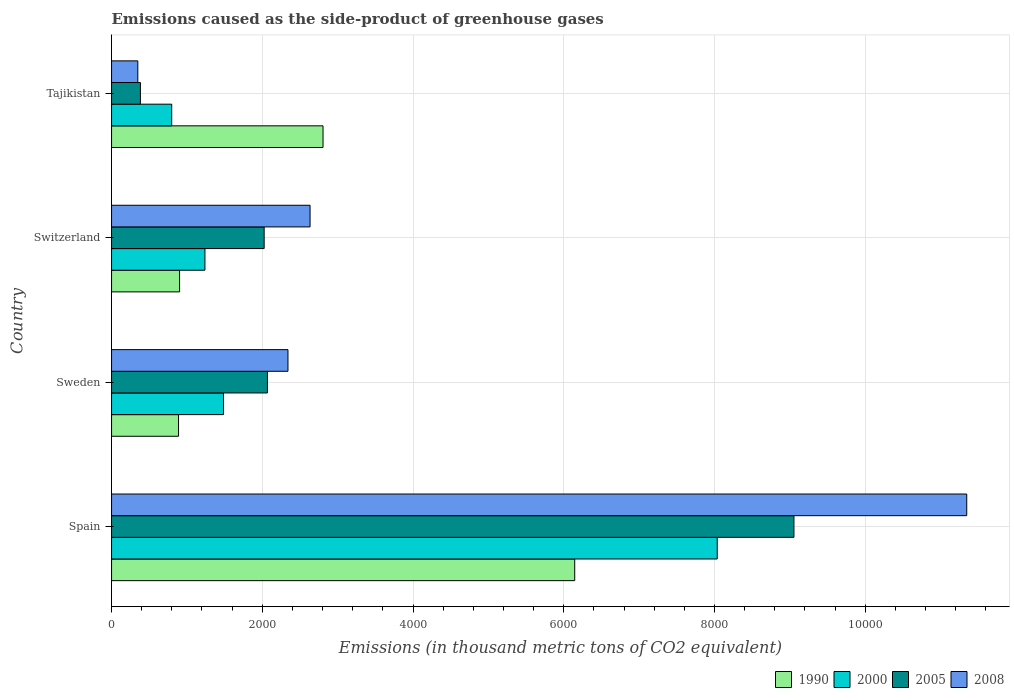How many groups of bars are there?
Your response must be concise. 4. Are the number of bars per tick equal to the number of legend labels?
Give a very brief answer. Yes. What is the label of the 1st group of bars from the top?
Your answer should be compact. Tajikistan. In how many cases, is the number of bars for a given country not equal to the number of legend labels?
Your answer should be very brief. 0. What is the emissions caused as the side-product of greenhouse gases in 2008 in Switzerland?
Offer a very short reply. 2634.1. Across all countries, what is the maximum emissions caused as the side-product of greenhouse gases in 1990?
Make the answer very short. 6146. Across all countries, what is the minimum emissions caused as the side-product of greenhouse gases in 1990?
Keep it short and to the point. 888.6. In which country was the emissions caused as the side-product of greenhouse gases in 2000 maximum?
Make the answer very short. Spain. In which country was the emissions caused as the side-product of greenhouse gases in 2005 minimum?
Offer a very short reply. Tajikistan. What is the total emissions caused as the side-product of greenhouse gases in 1990 in the graph?
Offer a very short reply. 1.07e+04. What is the difference between the emissions caused as the side-product of greenhouse gases in 2008 in Spain and that in Tajikistan?
Ensure brevity in your answer.  1.10e+04. What is the difference between the emissions caused as the side-product of greenhouse gases in 2005 in Tajikistan and the emissions caused as the side-product of greenhouse gases in 1990 in Sweden?
Make the answer very short. -505.6. What is the average emissions caused as the side-product of greenhouse gases in 1990 per country?
Offer a terse response. 2685.83. What is the difference between the emissions caused as the side-product of greenhouse gases in 2000 and emissions caused as the side-product of greenhouse gases in 2005 in Sweden?
Offer a terse response. -583.1. In how many countries, is the emissions caused as the side-product of greenhouse gases in 1990 greater than 9600 thousand metric tons?
Ensure brevity in your answer.  0. What is the ratio of the emissions caused as the side-product of greenhouse gases in 2008 in Sweden to that in Tajikistan?
Keep it short and to the point. 6.72. Is the emissions caused as the side-product of greenhouse gases in 2008 in Spain less than that in Switzerland?
Ensure brevity in your answer.  No. Is the difference between the emissions caused as the side-product of greenhouse gases in 2000 in Spain and Switzerland greater than the difference between the emissions caused as the side-product of greenhouse gases in 2005 in Spain and Switzerland?
Offer a very short reply. No. What is the difference between the highest and the second highest emissions caused as the side-product of greenhouse gases in 1990?
Make the answer very short. 3339.9. What is the difference between the highest and the lowest emissions caused as the side-product of greenhouse gases in 2000?
Keep it short and to the point. 7239.1. What does the 3rd bar from the top in Spain represents?
Your response must be concise. 2000. What does the 4th bar from the bottom in Switzerland represents?
Your answer should be very brief. 2008. Is it the case that in every country, the sum of the emissions caused as the side-product of greenhouse gases in 2005 and emissions caused as the side-product of greenhouse gases in 2008 is greater than the emissions caused as the side-product of greenhouse gases in 2000?
Your answer should be very brief. No. How many bars are there?
Offer a very short reply. 16. How many countries are there in the graph?
Your answer should be compact. 4. What is the difference between two consecutive major ticks on the X-axis?
Offer a very short reply. 2000. Does the graph contain any zero values?
Make the answer very short. No. Does the graph contain grids?
Offer a very short reply. Yes. Where does the legend appear in the graph?
Ensure brevity in your answer.  Bottom right. How are the legend labels stacked?
Your answer should be compact. Horizontal. What is the title of the graph?
Provide a short and direct response. Emissions caused as the side-product of greenhouse gases. What is the label or title of the X-axis?
Make the answer very short. Emissions (in thousand metric tons of CO2 equivalent). What is the label or title of the Y-axis?
Ensure brevity in your answer.  Country. What is the Emissions (in thousand metric tons of CO2 equivalent) in 1990 in Spain?
Make the answer very short. 6146. What is the Emissions (in thousand metric tons of CO2 equivalent) of 2000 in Spain?
Make the answer very short. 8037.1. What is the Emissions (in thousand metric tons of CO2 equivalent) in 2005 in Spain?
Keep it short and to the point. 9055.1. What is the Emissions (in thousand metric tons of CO2 equivalent) in 2008 in Spain?
Keep it short and to the point. 1.13e+04. What is the Emissions (in thousand metric tons of CO2 equivalent) in 1990 in Sweden?
Provide a succinct answer. 888.6. What is the Emissions (in thousand metric tons of CO2 equivalent) of 2000 in Sweden?
Your answer should be compact. 1485.3. What is the Emissions (in thousand metric tons of CO2 equivalent) in 2005 in Sweden?
Provide a short and direct response. 2068.4. What is the Emissions (in thousand metric tons of CO2 equivalent) in 2008 in Sweden?
Offer a very short reply. 2340.9. What is the Emissions (in thousand metric tons of CO2 equivalent) of 1990 in Switzerland?
Offer a terse response. 902.6. What is the Emissions (in thousand metric tons of CO2 equivalent) of 2000 in Switzerland?
Keep it short and to the point. 1239.2. What is the Emissions (in thousand metric tons of CO2 equivalent) in 2005 in Switzerland?
Your answer should be very brief. 2025. What is the Emissions (in thousand metric tons of CO2 equivalent) of 2008 in Switzerland?
Offer a terse response. 2634.1. What is the Emissions (in thousand metric tons of CO2 equivalent) of 1990 in Tajikistan?
Make the answer very short. 2806.1. What is the Emissions (in thousand metric tons of CO2 equivalent) in 2000 in Tajikistan?
Provide a short and direct response. 798. What is the Emissions (in thousand metric tons of CO2 equivalent) of 2005 in Tajikistan?
Provide a short and direct response. 383. What is the Emissions (in thousand metric tons of CO2 equivalent) of 2008 in Tajikistan?
Provide a short and direct response. 348.3. Across all countries, what is the maximum Emissions (in thousand metric tons of CO2 equivalent) in 1990?
Your answer should be compact. 6146. Across all countries, what is the maximum Emissions (in thousand metric tons of CO2 equivalent) in 2000?
Offer a very short reply. 8037.1. Across all countries, what is the maximum Emissions (in thousand metric tons of CO2 equivalent) in 2005?
Your answer should be compact. 9055.1. Across all countries, what is the maximum Emissions (in thousand metric tons of CO2 equivalent) in 2008?
Provide a succinct answer. 1.13e+04. Across all countries, what is the minimum Emissions (in thousand metric tons of CO2 equivalent) in 1990?
Ensure brevity in your answer.  888.6. Across all countries, what is the minimum Emissions (in thousand metric tons of CO2 equivalent) in 2000?
Provide a short and direct response. 798. Across all countries, what is the minimum Emissions (in thousand metric tons of CO2 equivalent) of 2005?
Offer a very short reply. 383. Across all countries, what is the minimum Emissions (in thousand metric tons of CO2 equivalent) of 2008?
Your answer should be compact. 348.3. What is the total Emissions (in thousand metric tons of CO2 equivalent) in 1990 in the graph?
Your answer should be very brief. 1.07e+04. What is the total Emissions (in thousand metric tons of CO2 equivalent) of 2000 in the graph?
Provide a succinct answer. 1.16e+04. What is the total Emissions (in thousand metric tons of CO2 equivalent) in 2005 in the graph?
Give a very brief answer. 1.35e+04. What is the total Emissions (in thousand metric tons of CO2 equivalent) of 2008 in the graph?
Provide a succinct answer. 1.67e+04. What is the difference between the Emissions (in thousand metric tons of CO2 equivalent) of 1990 in Spain and that in Sweden?
Provide a short and direct response. 5257.4. What is the difference between the Emissions (in thousand metric tons of CO2 equivalent) of 2000 in Spain and that in Sweden?
Ensure brevity in your answer.  6551.8. What is the difference between the Emissions (in thousand metric tons of CO2 equivalent) in 2005 in Spain and that in Sweden?
Ensure brevity in your answer.  6986.7. What is the difference between the Emissions (in thousand metric tons of CO2 equivalent) in 2008 in Spain and that in Sweden?
Ensure brevity in your answer.  9006.9. What is the difference between the Emissions (in thousand metric tons of CO2 equivalent) of 1990 in Spain and that in Switzerland?
Offer a terse response. 5243.4. What is the difference between the Emissions (in thousand metric tons of CO2 equivalent) of 2000 in Spain and that in Switzerland?
Your answer should be very brief. 6797.9. What is the difference between the Emissions (in thousand metric tons of CO2 equivalent) of 2005 in Spain and that in Switzerland?
Give a very brief answer. 7030.1. What is the difference between the Emissions (in thousand metric tons of CO2 equivalent) of 2008 in Spain and that in Switzerland?
Your answer should be very brief. 8713.7. What is the difference between the Emissions (in thousand metric tons of CO2 equivalent) in 1990 in Spain and that in Tajikistan?
Ensure brevity in your answer.  3339.9. What is the difference between the Emissions (in thousand metric tons of CO2 equivalent) of 2000 in Spain and that in Tajikistan?
Keep it short and to the point. 7239.1. What is the difference between the Emissions (in thousand metric tons of CO2 equivalent) in 2005 in Spain and that in Tajikistan?
Provide a succinct answer. 8672.1. What is the difference between the Emissions (in thousand metric tons of CO2 equivalent) in 2008 in Spain and that in Tajikistan?
Offer a terse response. 1.10e+04. What is the difference between the Emissions (in thousand metric tons of CO2 equivalent) of 1990 in Sweden and that in Switzerland?
Offer a very short reply. -14. What is the difference between the Emissions (in thousand metric tons of CO2 equivalent) of 2000 in Sweden and that in Switzerland?
Keep it short and to the point. 246.1. What is the difference between the Emissions (in thousand metric tons of CO2 equivalent) of 2005 in Sweden and that in Switzerland?
Provide a succinct answer. 43.4. What is the difference between the Emissions (in thousand metric tons of CO2 equivalent) of 2008 in Sweden and that in Switzerland?
Your answer should be compact. -293.2. What is the difference between the Emissions (in thousand metric tons of CO2 equivalent) of 1990 in Sweden and that in Tajikistan?
Your answer should be very brief. -1917.5. What is the difference between the Emissions (in thousand metric tons of CO2 equivalent) in 2000 in Sweden and that in Tajikistan?
Keep it short and to the point. 687.3. What is the difference between the Emissions (in thousand metric tons of CO2 equivalent) in 2005 in Sweden and that in Tajikistan?
Keep it short and to the point. 1685.4. What is the difference between the Emissions (in thousand metric tons of CO2 equivalent) in 2008 in Sweden and that in Tajikistan?
Make the answer very short. 1992.6. What is the difference between the Emissions (in thousand metric tons of CO2 equivalent) of 1990 in Switzerland and that in Tajikistan?
Offer a terse response. -1903.5. What is the difference between the Emissions (in thousand metric tons of CO2 equivalent) in 2000 in Switzerland and that in Tajikistan?
Make the answer very short. 441.2. What is the difference between the Emissions (in thousand metric tons of CO2 equivalent) in 2005 in Switzerland and that in Tajikistan?
Provide a succinct answer. 1642. What is the difference between the Emissions (in thousand metric tons of CO2 equivalent) in 2008 in Switzerland and that in Tajikistan?
Offer a terse response. 2285.8. What is the difference between the Emissions (in thousand metric tons of CO2 equivalent) of 1990 in Spain and the Emissions (in thousand metric tons of CO2 equivalent) of 2000 in Sweden?
Ensure brevity in your answer.  4660.7. What is the difference between the Emissions (in thousand metric tons of CO2 equivalent) of 1990 in Spain and the Emissions (in thousand metric tons of CO2 equivalent) of 2005 in Sweden?
Offer a very short reply. 4077.6. What is the difference between the Emissions (in thousand metric tons of CO2 equivalent) in 1990 in Spain and the Emissions (in thousand metric tons of CO2 equivalent) in 2008 in Sweden?
Your answer should be compact. 3805.1. What is the difference between the Emissions (in thousand metric tons of CO2 equivalent) in 2000 in Spain and the Emissions (in thousand metric tons of CO2 equivalent) in 2005 in Sweden?
Give a very brief answer. 5968.7. What is the difference between the Emissions (in thousand metric tons of CO2 equivalent) in 2000 in Spain and the Emissions (in thousand metric tons of CO2 equivalent) in 2008 in Sweden?
Offer a terse response. 5696.2. What is the difference between the Emissions (in thousand metric tons of CO2 equivalent) of 2005 in Spain and the Emissions (in thousand metric tons of CO2 equivalent) of 2008 in Sweden?
Offer a terse response. 6714.2. What is the difference between the Emissions (in thousand metric tons of CO2 equivalent) of 1990 in Spain and the Emissions (in thousand metric tons of CO2 equivalent) of 2000 in Switzerland?
Your answer should be compact. 4906.8. What is the difference between the Emissions (in thousand metric tons of CO2 equivalent) in 1990 in Spain and the Emissions (in thousand metric tons of CO2 equivalent) in 2005 in Switzerland?
Provide a short and direct response. 4121. What is the difference between the Emissions (in thousand metric tons of CO2 equivalent) of 1990 in Spain and the Emissions (in thousand metric tons of CO2 equivalent) of 2008 in Switzerland?
Offer a very short reply. 3511.9. What is the difference between the Emissions (in thousand metric tons of CO2 equivalent) in 2000 in Spain and the Emissions (in thousand metric tons of CO2 equivalent) in 2005 in Switzerland?
Provide a succinct answer. 6012.1. What is the difference between the Emissions (in thousand metric tons of CO2 equivalent) in 2000 in Spain and the Emissions (in thousand metric tons of CO2 equivalent) in 2008 in Switzerland?
Your answer should be compact. 5403. What is the difference between the Emissions (in thousand metric tons of CO2 equivalent) of 2005 in Spain and the Emissions (in thousand metric tons of CO2 equivalent) of 2008 in Switzerland?
Your response must be concise. 6421. What is the difference between the Emissions (in thousand metric tons of CO2 equivalent) in 1990 in Spain and the Emissions (in thousand metric tons of CO2 equivalent) in 2000 in Tajikistan?
Keep it short and to the point. 5348. What is the difference between the Emissions (in thousand metric tons of CO2 equivalent) of 1990 in Spain and the Emissions (in thousand metric tons of CO2 equivalent) of 2005 in Tajikistan?
Offer a terse response. 5763. What is the difference between the Emissions (in thousand metric tons of CO2 equivalent) in 1990 in Spain and the Emissions (in thousand metric tons of CO2 equivalent) in 2008 in Tajikistan?
Keep it short and to the point. 5797.7. What is the difference between the Emissions (in thousand metric tons of CO2 equivalent) in 2000 in Spain and the Emissions (in thousand metric tons of CO2 equivalent) in 2005 in Tajikistan?
Your response must be concise. 7654.1. What is the difference between the Emissions (in thousand metric tons of CO2 equivalent) of 2000 in Spain and the Emissions (in thousand metric tons of CO2 equivalent) of 2008 in Tajikistan?
Offer a terse response. 7688.8. What is the difference between the Emissions (in thousand metric tons of CO2 equivalent) of 2005 in Spain and the Emissions (in thousand metric tons of CO2 equivalent) of 2008 in Tajikistan?
Provide a short and direct response. 8706.8. What is the difference between the Emissions (in thousand metric tons of CO2 equivalent) in 1990 in Sweden and the Emissions (in thousand metric tons of CO2 equivalent) in 2000 in Switzerland?
Your answer should be compact. -350.6. What is the difference between the Emissions (in thousand metric tons of CO2 equivalent) in 1990 in Sweden and the Emissions (in thousand metric tons of CO2 equivalent) in 2005 in Switzerland?
Ensure brevity in your answer.  -1136.4. What is the difference between the Emissions (in thousand metric tons of CO2 equivalent) of 1990 in Sweden and the Emissions (in thousand metric tons of CO2 equivalent) of 2008 in Switzerland?
Your answer should be compact. -1745.5. What is the difference between the Emissions (in thousand metric tons of CO2 equivalent) in 2000 in Sweden and the Emissions (in thousand metric tons of CO2 equivalent) in 2005 in Switzerland?
Offer a very short reply. -539.7. What is the difference between the Emissions (in thousand metric tons of CO2 equivalent) of 2000 in Sweden and the Emissions (in thousand metric tons of CO2 equivalent) of 2008 in Switzerland?
Your answer should be compact. -1148.8. What is the difference between the Emissions (in thousand metric tons of CO2 equivalent) in 2005 in Sweden and the Emissions (in thousand metric tons of CO2 equivalent) in 2008 in Switzerland?
Ensure brevity in your answer.  -565.7. What is the difference between the Emissions (in thousand metric tons of CO2 equivalent) of 1990 in Sweden and the Emissions (in thousand metric tons of CO2 equivalent) of 2000 in Tajikistan?
Provide a succinct answer. 90.6. What is the difference between the Emissions (in thousand metric tons of CO2 equivalent) in 1990 in Sweden and the Emissions (in thousand metric tons of CO2 equivalent) in 2005 in Tajikistan?
Offer a terse response. 505.6. What is the difference between the Emissions (in thousand metric tons of CO2 equivalent) in 1990 in Sweden and the Emissions (in thousand metric tons of CO2 equivalent) in 2008 in Tajikistan?
Provide a succinct answer. 540.3. What is the difference between the Emissions (in thousand metric tons of CO2 equivalent) in 2000 in Sweden and the Emissions (in thousand metric tons of CO2 equivalent) in 2005 in Tajikistan?
Offer a terse response. 1102.3. What is the difference between the Emissions (in thousand metric tons of CO2 equivalent) in 2000 in Sweden and the Emissions (in thousand metric tons of CO2 equivalent) in 2008 in Tajikistan?
Keep it short and to the point. 1137. What is the difference between the Emissions (in thousand metric tons of CO2 equivalent) in 2005 in Sweden and the Emissions (in thousand metric tons of CO2 equivalent) in 2008 in Tajikistan?
Your response must be concise. 1720.1. What is the difference between the Emissions (in thousand metric tons of CO2 equivalent) of 1990 in Switzerland and the Emissions (in thousand metric tons of CO2 equivalent) of 2000 in Tajikistan?
Offer a terse response. 104.6. What is the difference between the Emissions (in thousand metric tons of CO2 equivalent) in 1990 in Switzerland and the Emissions (in thousand metric tons of CO2 equivalent) in 2005 in Tajikistan?
Provide a succinct answer. 519.6. What is the difference between the Emissions (in thousand metric tons of CO2 equivalent) in 1990 in Switzerland and the Emissions (in thousand metric tons of CO2 equivalent) in 2008 in Tajikistan?
Ensure brevity in your answer.  554.3. What is the difference between the Emissions (in thousand metric tons of CO2 equivalent) in 2000 in Switzerland and the Emissions (in thousand metric tons of CO2 equivalent) in 2005 in Tajikistan?
Ensure brevity in your answer.  856.2. What is the difference between the Emissions (in thousand metric tons of CO2 equivalent) of 2000 in Switzerland and the Emissions (in thousand metric tons of CO2 equivalent) of 2008 in Tajikistan?
Give a very brief answer. 890.9. What is the difference between the Emissions (in thousand metric tons of CO2 equivalent) in 2005 in Switzerland and the Emissions (in thousand metric tons of CO2 equivalent) in 2008 in Tajikistan?
Provide a short and direct response. 1676.7. What is the average Emissions (in thousand metric tons of CO2 equivalent) in 1990 per country?
Make the answer very short. 2685.82. What is the average Emissions (in thousand metric tons of CO2 equivalent) in 2000 per country?
Your answer should be compact. 2889.9. What is the average Emissions (in thousand metric tons of CO2 equivalent) in 2005 per country?
Your answer should be very brief. 3382.88. What is the average Emissions (in thousand metric tons of CO2 equivalent) in 2008 per country?
Ensure brevity in your answer.  4167.77. What is the difference between the Emissions (in thousand metric tons of CO2 equivalent) of 1990 and Emissions (in thousand metric tons of CO2 equivalent) of 2000 in Spain?
Provide a succinct answer. -1891.1. What is the difference between the Emissions (in thousand metric tons of CO2 equivalent) in 1990 and Emissions (in thousand metric tons of CO2 equivalent) in 2005 in Spain?
Give a very brief answer. -2909.1. What is the difference between the Emissions (in thousand metric tons of CO2 equivalent) in 1990 and Emissions (in thousand metric tons of CO2 equivalent) in 2008 in Spain?
Offer a terse response. -5201.8. What is the difference between the Emissions (in thousand metric tons of CO2 equivalent) in 2000 and Emissions (in thousand metric tons of CO2 equivalent) in 2005 in Spain?
Your answer should be compact. -1018. What is the difference between the Emissions (in thousand metric tons of CO2 equivalent) in 2000 and Emissions (in thousand metric tons of CO2 equivalent) in 2008 in Spain?
Your answer should be compact. -3310.7. What is the difference between the Emissions (in thousand metric tons of CO2 equivalent) in 2005 and Emissions (in thousand metric tons of CO2 equivalent) in 2008 in Spain?
Your answer should be compact. -2292.7. What is the difference between the Emissions (in thousand metric tons of CO2 equivalent) in 1990 and Emissions (in thousand metric tons of CO2 equivalent) in 2000 in Sweden?
Keep it short and to the point. -596.7. What is the difference between the Emissions (in thousand metric tons of CO2 equivalent) in 1990 and Emissions (in thousand metric tons of CO2 equivalent) in 2005 in Sweden?
Offer a very short reply. -1179.8. What is the difference between the Emissions (in thousand metric tons of CO2 equivalent) in 1990 and Emissions (in thousand metric tons of CO2 equivalent) in 2008 in Sweden?
Give a very brief answer. -1452.3. What is the difference between the Emissions (in thousand metric tons of CO2 equivalent) of 2000 and Emissions (in thousand metric tons of CO2 equivalent) of 2005 in Sweden?
Make the answer very short. -583.1. What is the difference between the Emissions (in thousand metric tons of CO2 equivalent) of 2000 and Emissions (in thousand metric tons of CO2 equivalent) of 2008 in Sweden?
Make the answer very short. -855.6. What is the difference between the Emissions (in thousand metric tons of CO2 equivalent) of 2005 and Emissions (in thousand metric tons of CO2 equivalent) of 2008 in Sweden?
Your answer should be compact. -272.5. What is the difference between the Emissions (in thousand metric tons of CO2 equivalent) of 1990 and Emissions (in thousand metric tons of CO2 equivalent) of 2000 in Switzerland?
Ensure brevity in your answer.  -336.6. What is the difference between the Emissions (in thousand metric tons of CO2 equivalent) of 1990 and Emissions (in thousand metric tons of CO2 equivalent) of 2005 in Switzerland?
Your response must be concise. -1122.4. What is the difference between the Emissions (in thousand metric tons of CO2 equivalent) of 1990 and Emissions (in thousand metric tons of CO2 equivalent) of 2008 in Switzerland?
Offer a terse response. -1731.5. What is the difference between the Emissions (in thousand metric tons of CO2 equivalent) of 2000 and Emissions (in thousand metric tons of CO2 equivalent) of 2005 in Switzerland?
Make the answer very short. -785.8. What is the difference between the Emissions (in thousand metric tons of CO2 equivalent) of 2000 and Emissions (in thousand metric tons of CO2 equivalent) of 2008 in Switzerland?
Ensure brevity in your answer.  -1394.9. What is the difference between the Emissions (in thousand metric tons of CO2 equivalent) of 2005 and Emissions (in thousand metric tons of CO2 equivalent) of 2008 in Switzerland?
Your response must be concise. -609.1. What is the difference between the Emissions (in thousand metric tons of CO2 equivalent) of 1990 and Emissions (in thousand metric tons of CO2 equivalent) of 2000 in Tajikistan?
Offer a terse response. 2008.1. What is the difference between the Emissions (in thousand metric tons of CO2 equivalent) of 1990 and Emissions (in thousand metric tons of CO2 equivalent) of 2005 in Tajikistan?
Ensure brevity in your answer.  2423.1. What is the difference between the Emissions (in thousand metric tons of CO2 equivalent) in 1990 and Emissions (in thousand metric tons of CO2 equivalent) in 2008 in Tajikistan?
Make the answer very short. 2457.8. What is the difference between the Emissions (in thousand metric tons of CO2 equivalent) of 2000 and Emissions (in thousand metric tons of CO2 equivalent) of 2005 in Tajikistan?
Your response must be concise. 415. What is the difference between the Emissions (in thousand metric tons of CO2 equivalent) of 2000 and Emissions (in thousand metric tons of CO2 equivalent) of 2008 in Tajikistan?
Give a very brief answer. 449.7. What is the difference between the Emissions (in thousand metric tons of CO2 equivalent) of 2005 and Emissions (in thousand metric tons of CO2 equivalent) of 2008 in Tajikistan?
Offer a very short reply. 34.7. What is the ratio of the Emissions (in thousand metric tons of CO2 equivalent) in 1990 in Spain to that in Sweden?
Ensure brevity in your answer.  6.92. What is the ratio of the Emissions (in thousand metric tons of CO2 equivalent) of 2000 in Spain to that in Sweden?
Your response must be concise. 5.41. What is the ratio of the Emissions (in thousand metric tons of CO2 equivalent) of 2005 in Spain to that in Sweden?
Provide a short and direct response. 4.38. What is the ratio of the Emissions (in thousand metric tons of CO2 equivalent) of 2008 in Spain to that in Sweden?
Give a very brief answer. 4.85. What is the ratio of the Emissions (in thousand metric tons of CO2 equivalent) of 1990 in Spain to that in Switzerland?
Give a very brief answer. 6.81. What is the ratio of the Emissions (in thousand metric tons of CO2 equivalent) in 2000 in Spain to that in Switzerland?
Provide a succinct answer. 6.49. What is the ratio of the Emissions (in thousand metric tons of CO2 equivalent) in 2005 in Spain to that in Switzerland?
Your answer should be compact. 4.47. What is the ratio of the Emissions (in thousand metric tons of CO2 equivalent) of 2008 in Spain to that in Switzerland?
Your response must be concise. 4.31. What is the ratio of the Emissions (in thousand metric tons of CO2 equivalent) of 1990 in Spain to that in Tajikistan?
Your response must be concise. 2.19. What is the ratio of the Emissions (in thousand metric tons of CO2 equivalent) of 2000 in Spain to that in Tajikistan?
Offer a very short reply. 10.07. What is the ratio of the Emissions (in thousand metric tons of CO2 equivalent) in 2005 in Spain to that in Tajikistan?
Give a very brief answer. 23.64. What is the ratio of the Emissions (in thousand metric tons of CO2 equivalent) of 2008 in Spain to that in Tajikistan?
Offer a very short reply. 32.58. What is the ratio of the Emissions (in thousand metric tons of CO2 equivalent) in 1990 in Sweden to that in Switzerland?
Keep it short and to the point. 0.98. What is the ratio of the Emissions (in thousand metric tons of CO2 equivalent) of 2000 in Sweden to that in Switzerland?
Keep it short and to the point. 1.2. What is the ratio of the Emissions (in thousand metric tons of CO2 equivalent) of 2005 in Sweden to that in Switzerland?
Make the answer very short. 1.02. What is the ratio of the Emissions (in thousand metric tons of CO2 equivalent) of 2008 in Sweden to that in Switzerland?
Make the answer very short. 0.89. What is the ratio of the Emissions (in thousand metric tons of CO2 equivalent) in 1990 in Sweden to that in Tajikistan?
Offer a very short reply. 0.32. What is the ratio of the Emissions (in thousand metric tons of CO2 equivalent) of 2000 in Sweden to that in Tajikistan?
Make the answer very short. 1.86. What is the ratio of the Emissions (in thousand metric tons of CO2 equivalent) of 2005 in Sweden to that in Tajikistan?
Offer a very short reply. 5.4. What is the ratio of the Emissions (in thousand metric tons of CO2 equivalent) of 2008 in Sweden to that in Tajikistan?
Provide a succinct answer. 6.72. What is the ratio of the Emissions (in thousand metric tons of CO2 equivalent) of 1990 in Switzerland to that in Tajikistan?
Your response must be concise. 0.32. What is the ratio of the Emissions (in thousand metric tons of CO2 equivalent) in 2000 in Switzerland to that in Tajikistan?
Ensure brevity in your answer.  1.55. What is the ratio of the Emissions (in thousand metric tons of CO2 equivalent) in 2005 in Switzerland to that in Tajikistan?
Make the answer very short. 5.29. What is the ratio of the Emissions (in thousand metric tons of CO2 equivalent) of 2008 in Switzerland to that in Tajikistan?
Provide a succinct answer. 7.56. What is the difference between the highest and the second highest Emissions (in thousand metric tons of CO2 equivalent) in 1990?
Your response must be concise. 3339.9. What is the difference between the highest and the second highest Emissions (in thousand metric tons of CO2 equivalent) of 2000?
Keep it short and to the point. 6551.8. What is the difference between the highest and the second highest Emissions (in thousand metric tons of CO2 equivalent) in 2005?
Provide a succinct answer. 6986.7. What is the difference between the highest and the second highest Emissions (in thousand metric tons of CO2 equivalent) in 2008?
Your answer should be compact. 8713.7. What is the difference between the highest and the lowest Emissions (in thousand metric tons of CO2 equivalent) in 1990?
Offer a terse response. 5257.4. What is the difference between the highest and the lowest Emissions (in thousand metric tons of CO2 equivalent) in 2000?
Your answer should be compact. 7239.1. What is the difference between the highest and the lowest Emissions (in thousand metric tons of CO2 equivalent) in 2005?
Provide a short and direct response. 8672.1. What is the difference between the highest and the lowest Emissions (in thousand metric tons of CO2 equivalent) in 2008?
Give a very brief answer. 1.10e+04. 